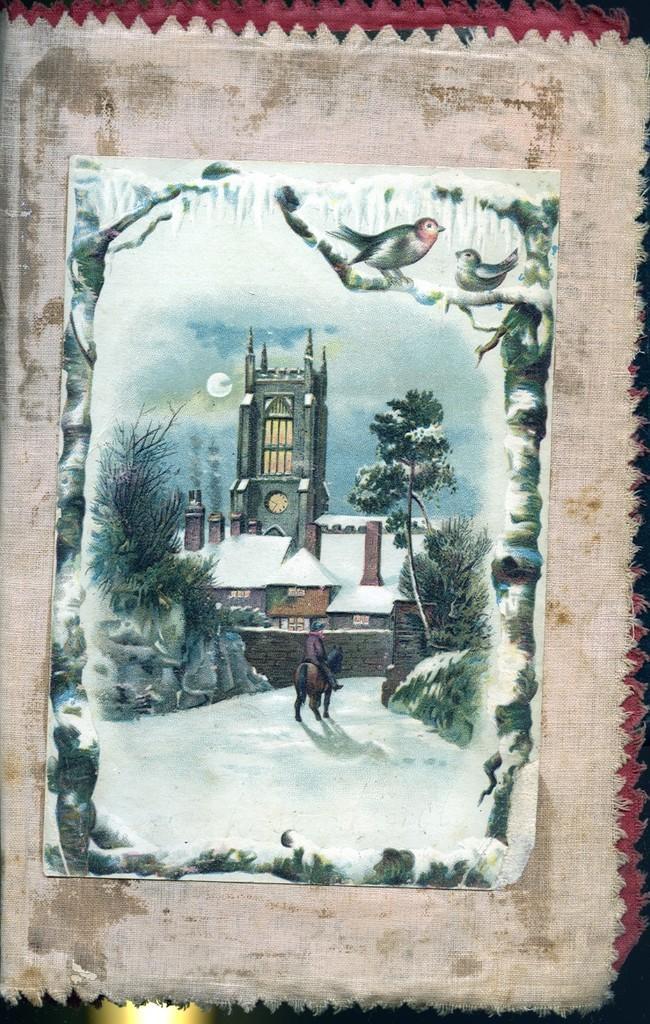Could you give a brief overview of what you see in this image? In the center of the image there is a painting in a cloth. 